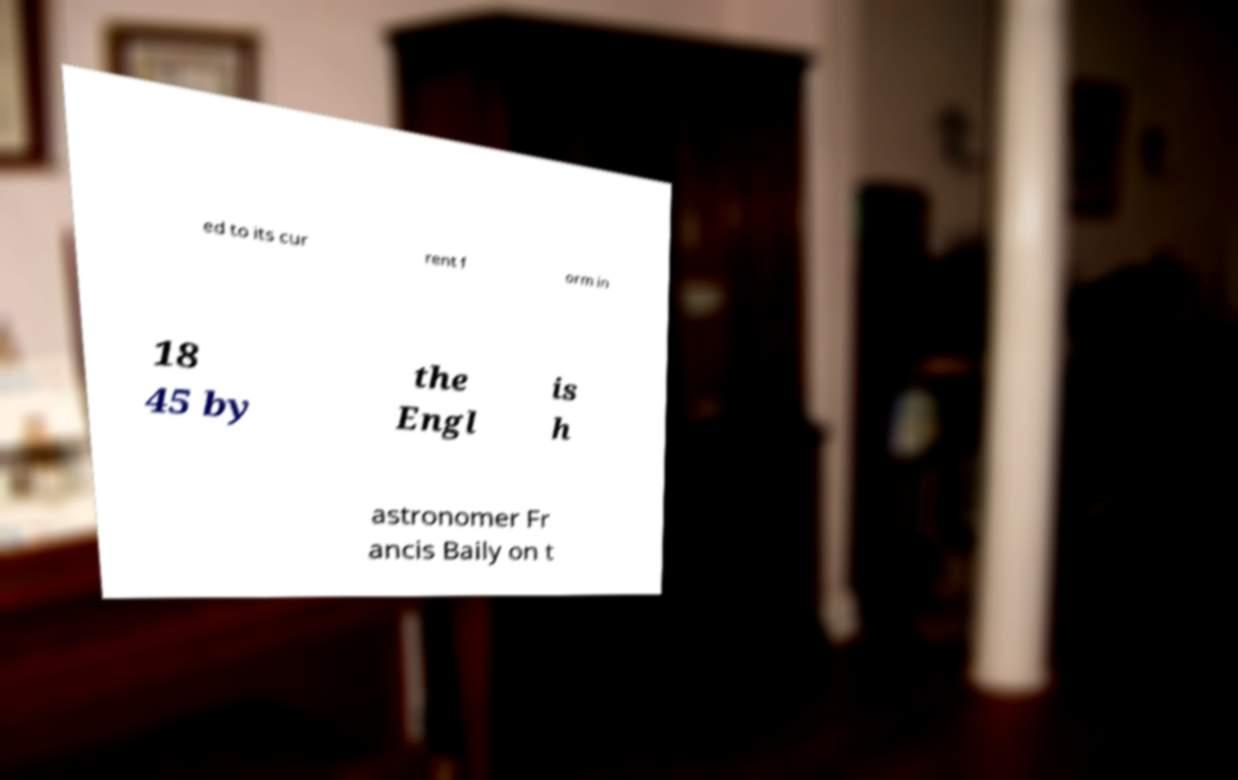There's text embedded in this image that I need extracted. Can you transcribe it verbatim? ed to its cur rent f orm in 18 45 by the Engl is h astronomer Fr ancis Baily on t 